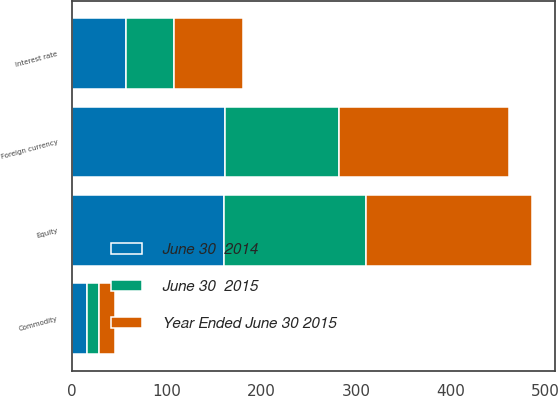<chart> <loc_0><loc_0><loc_500><loc_500><stacked_bar_chart><ecel><fcel>Foreign currency<fcel>Interest rate<fcel>Equity<fcel>Commodity<nl><fcel>June 30  2015<fcel>120<fcel>51<fcel>149<fcel>13<nl><fcel>Year Ended June 30 2015<fcel>179<fcel>73<fcel>176<fcel>17<nl><fcel>June 30  2014<fcel>162<fcel>57<fcel>161<fcel>16<nl></chart> 